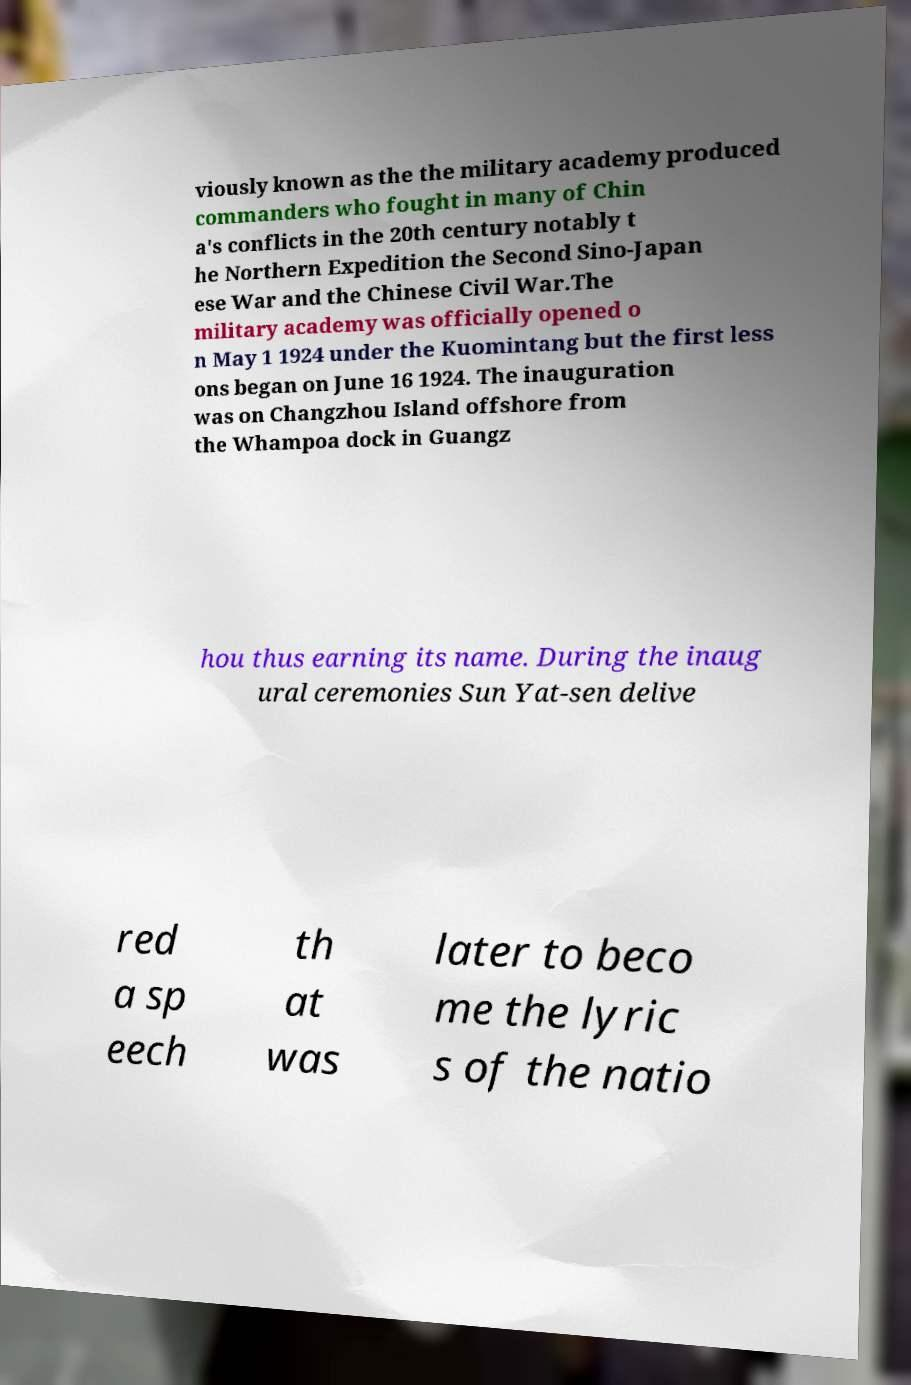Can you accurately transcribe the text from the provided image for me? viously known as the the military academy produced commanders who fought in many of Chin a's conflicts in the 20th century notably t he Northern Expedition the Second Sino-Japan ese War and the Chinese Civil War.The military academy was officially opened o n May 1 1924 under the Kuomintang but the first less ons began on June 16 1924. The inauguration was on Changzhou Island offshore from the Whampoa dock in Guangz hou thus earning its name. During the inaug ural ceremonies Sun Yat-sen delive red a sp eech th at was later to beco me the lyric s of the natio 